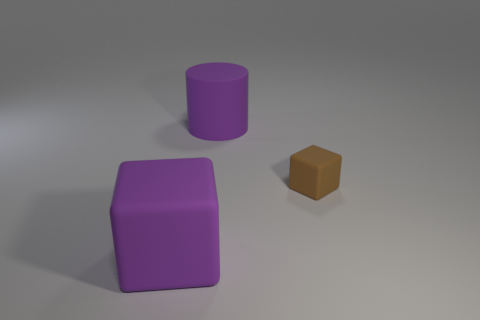Subtract all brown cubes. How many cubes are left? 1 Add 3 big cylinders. How many objects exist? 6 Subtract 1 purple cubes. How many objects are left? 2 Subtract all cylinders. How many objects are left? 2 Subtract 1 cylinders. How many cylinders are left? 0 Subtract all yellow cylinders. Subtract all cyan balls. How many cylinders are left? 1 Subtract all red spheres. How many purple cubes are left? 1 Subtract all red shiny balls. Subtract all purple rubber cylinders. How many objects are left? 2 Add 2 tiny blocks. How many tiny blocks are left? 3 Add 1 big cyan metallic blocks. How many big cyan metallic blocks exist? 1 